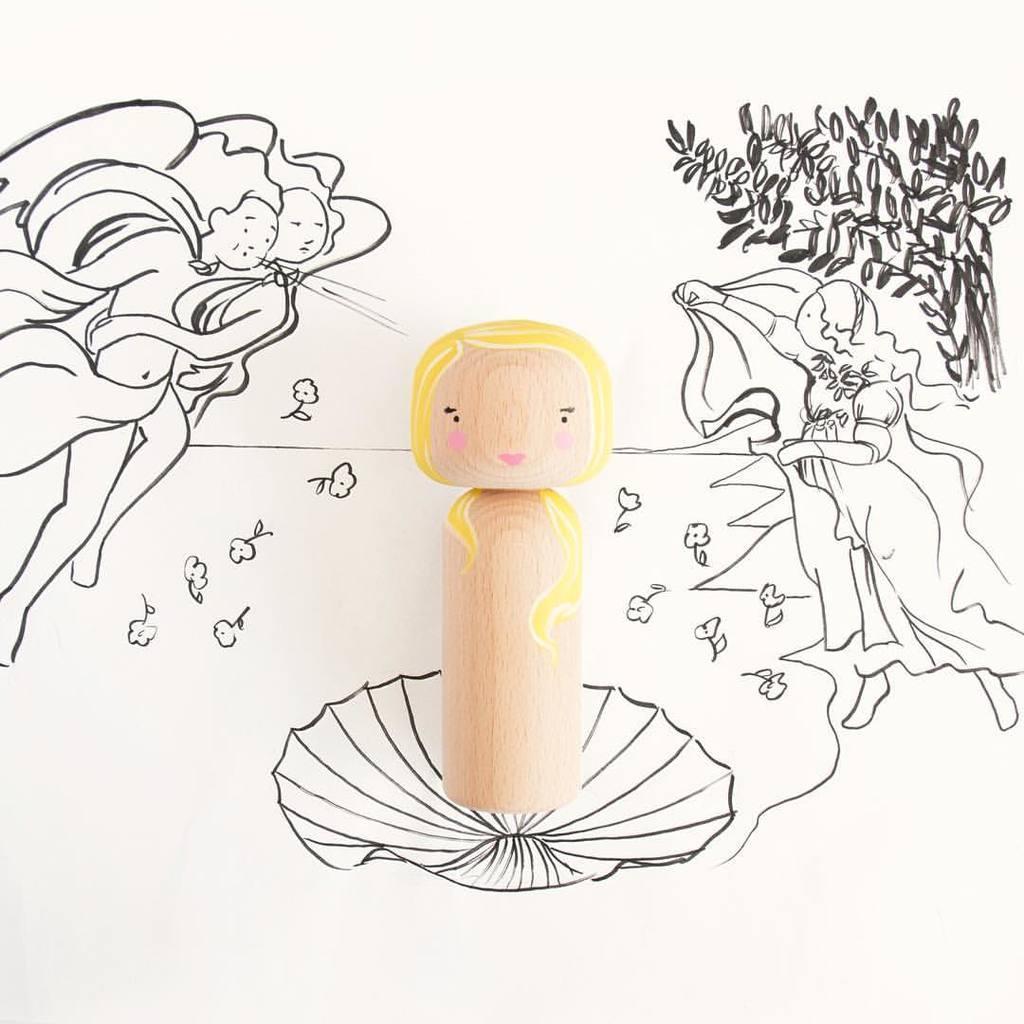Describe this image in one or two sentences. In this picture there is a doll which is made from the wood which is kept on the paper. In the paper I can see the painting of the women, flowers and plants. 